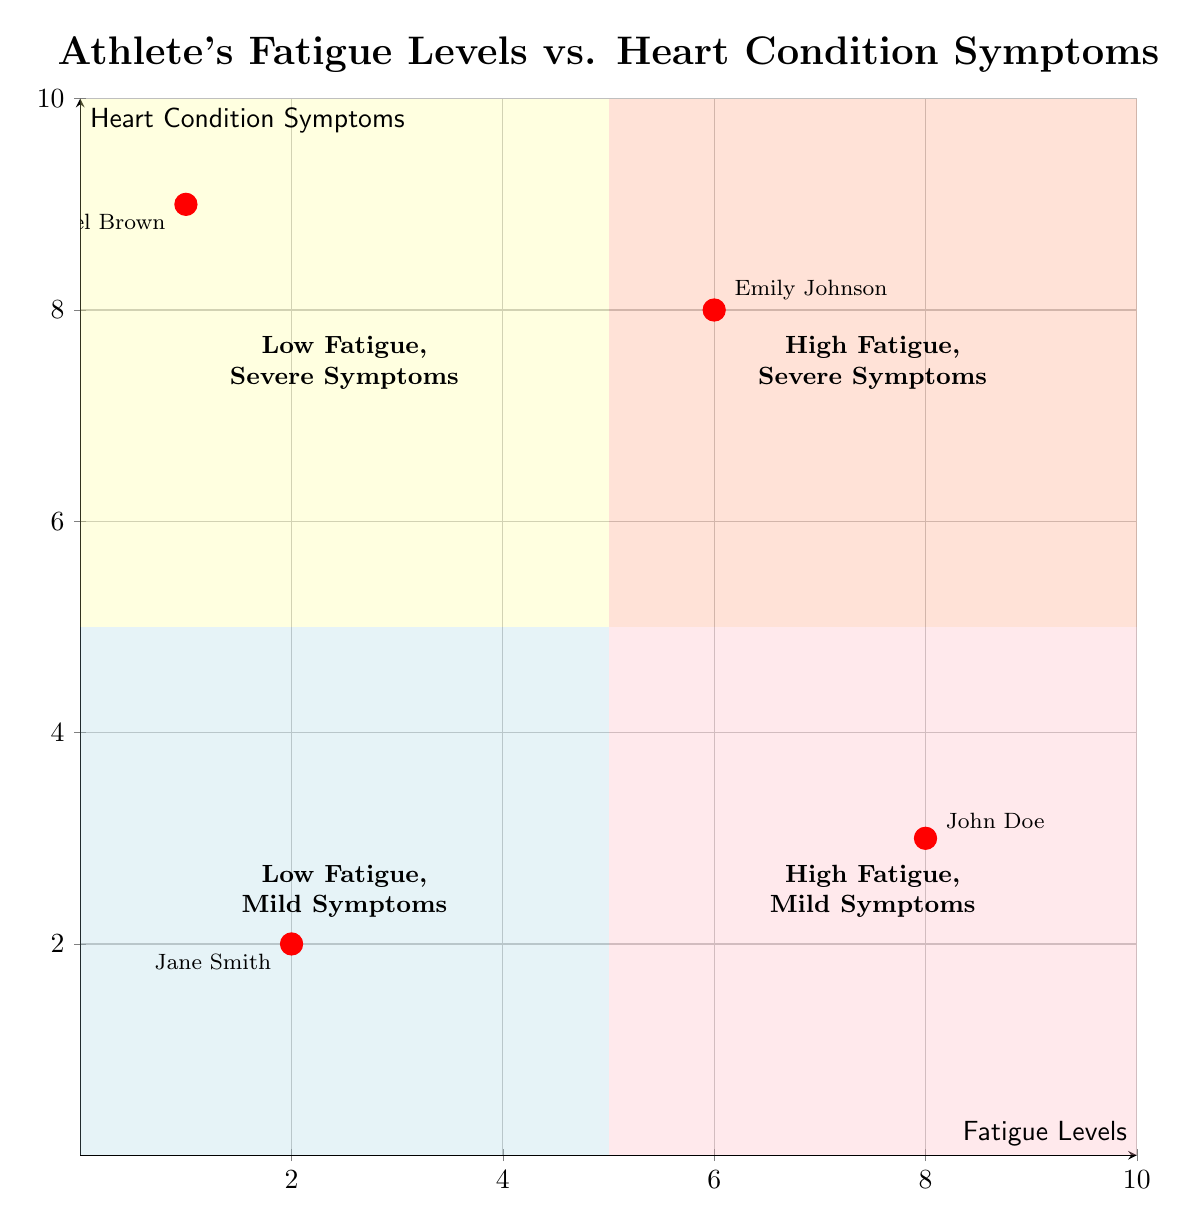What quadrant does "Jane Smith" fall into? Jane Smith's data point is located at coordinates (2,2), which is in the bottom left of the diagram. This area corresponds to the quadrant labeled "Low Fatigue, Mild Symptoms."
Answer: Low Fatigue, Mild Symptoms How many athletes are in the "High Fatigue, Severe Symptoms" quadrant? The "High Fatigue, Severe Symptoms" quadrant is located in the top right section of the chart, and upon inspection, only Emily Johnson's data point (6,8) is present there. Therefore, there is one athlete in this quadrant.
Answer: 1 What is the fatigue level of "John Doe"? John Doe's data point is marked at (8,3) on the chart. The x-coordinate indicates the fatigue level, which is 8.
Answer: 8 Which athlete has the highest heart condition symptom score? By checking the y-coordinates of all data points, Michael Brown has the highest score at y=9, showing that he has the most severe heart condition symptoms among the athletes in the chart.
Answer: Michael Brown What is the suggested action for "Emily Johnson"? Emily Johnson falls into the "High Fatigue, Severe Symptoms" quadrant. The suggestions in this quadrant advise to cease all training activities and seek urgent medical attention.
Answer: Cease all training activities What is the relationship between fatigue levels and heart condition symptoms for "Michael Brown"? Michael Brown's data point (1,9) indicates that he has low fatigue (1) but severe symptoms (9). This means that despite low fatigue, his heart condition is critical and needs immediate attention.
Answer: Low fatigue, severe symptoms What is the current training status of "John Doe"? John Doe's position (8,3) places him in the "High Fatigue, Mild Symptoms" quadrant, indicating that he is currently experiencing high fatigue with manageable heart condition symptoms.
Answer: High Fatigue, Mild Symptoms In which quadrant is training intensity suggested to be increased? The "Low Fatigue, Mild Symptoms" quadrant, where Jane Smith is located, suggests increasing workout intensity gradually due to optimal training conditions.
Answer: Low Fatigue, Mild Symptoms 